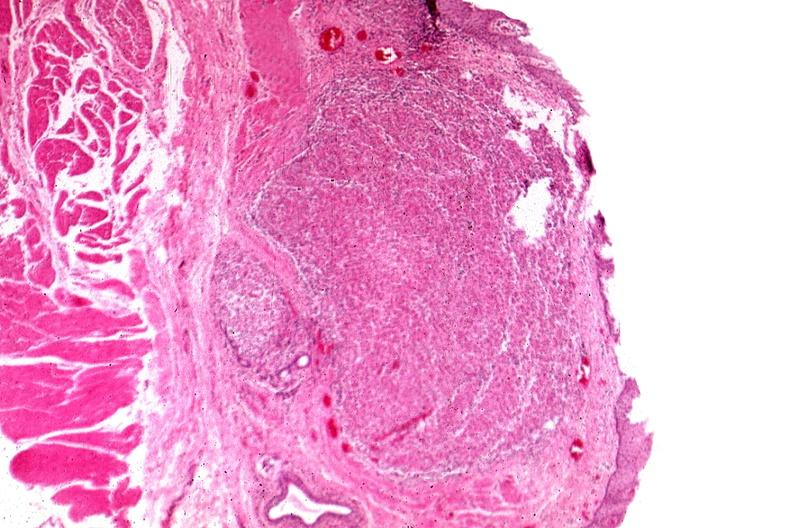what is present?
Answer the question using a single word or phrase. Sarcoidosis 